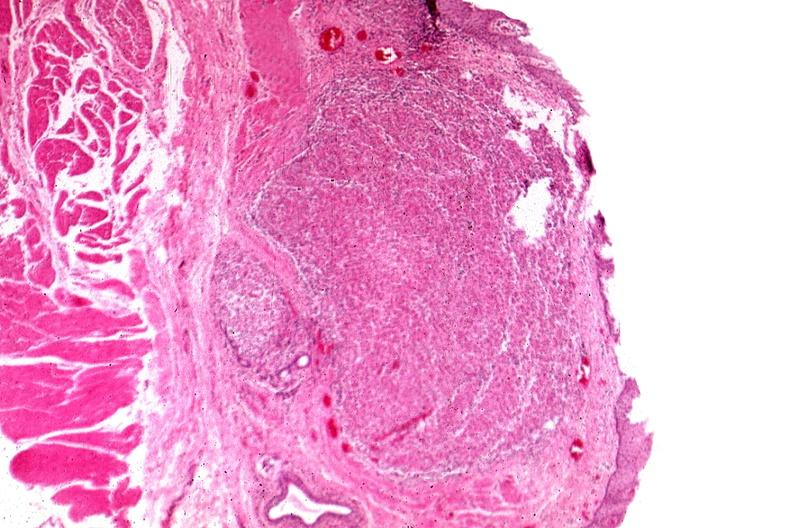what is present?
Answer the question using a single word or phrase. Sarcoidosis 